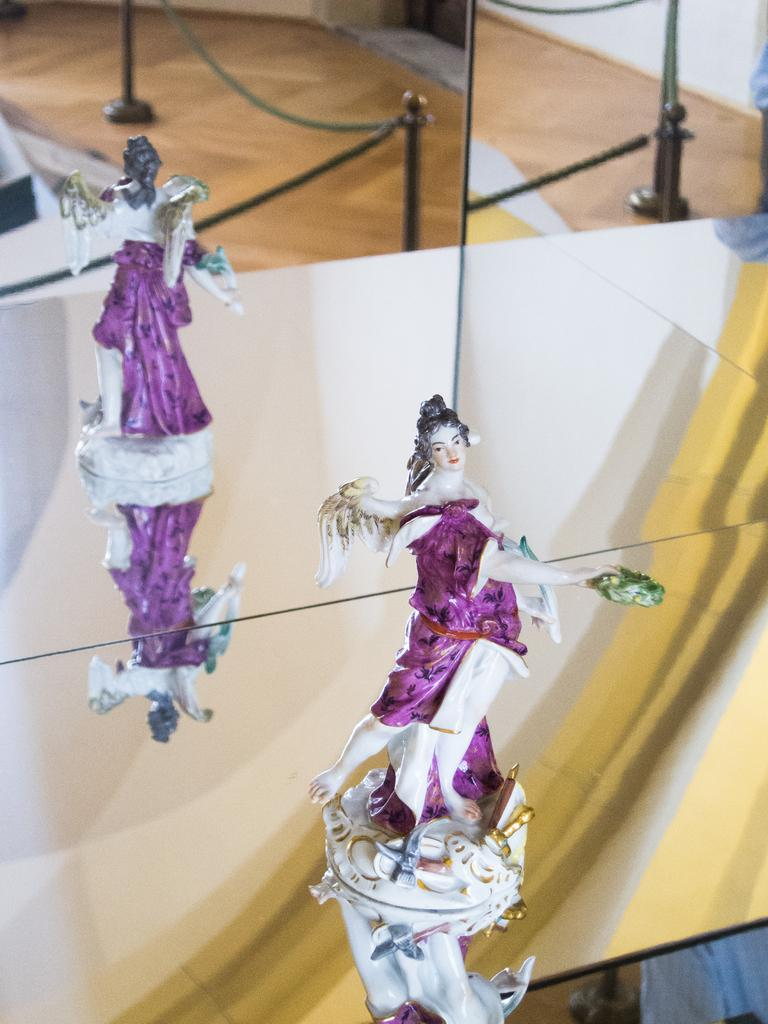What is the main subject of the image? There is a small sculpture of a woman in the image. How is the sculpture positioned? The sculpture is standing. What object in the image allows for reflection? There is a mirror in the image. What can be seen in the mirror's reflection? The reflection of the sculpture is visible in the mirror. What type of structure is present in the image? There is an iron chain with poles in the image. What type of instrument can be heard playing in the background of the image? There is no indication of any sound or instrument in the image, as it is a still photograph. 